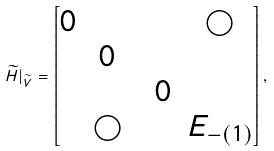Convert formula to latex. <formula><loc_0><loc_0><loc_500><loc_500>\widetilde { H } | _ { \widetilde { V } } = \left [ \begin{matrix} 0 & & & & \bigcirc \\ & 0 \\ & & & 0 \\ & \bigcirc & & & E _ { - ( 1 ) } \end{matrix} \right ] ,</formula> 